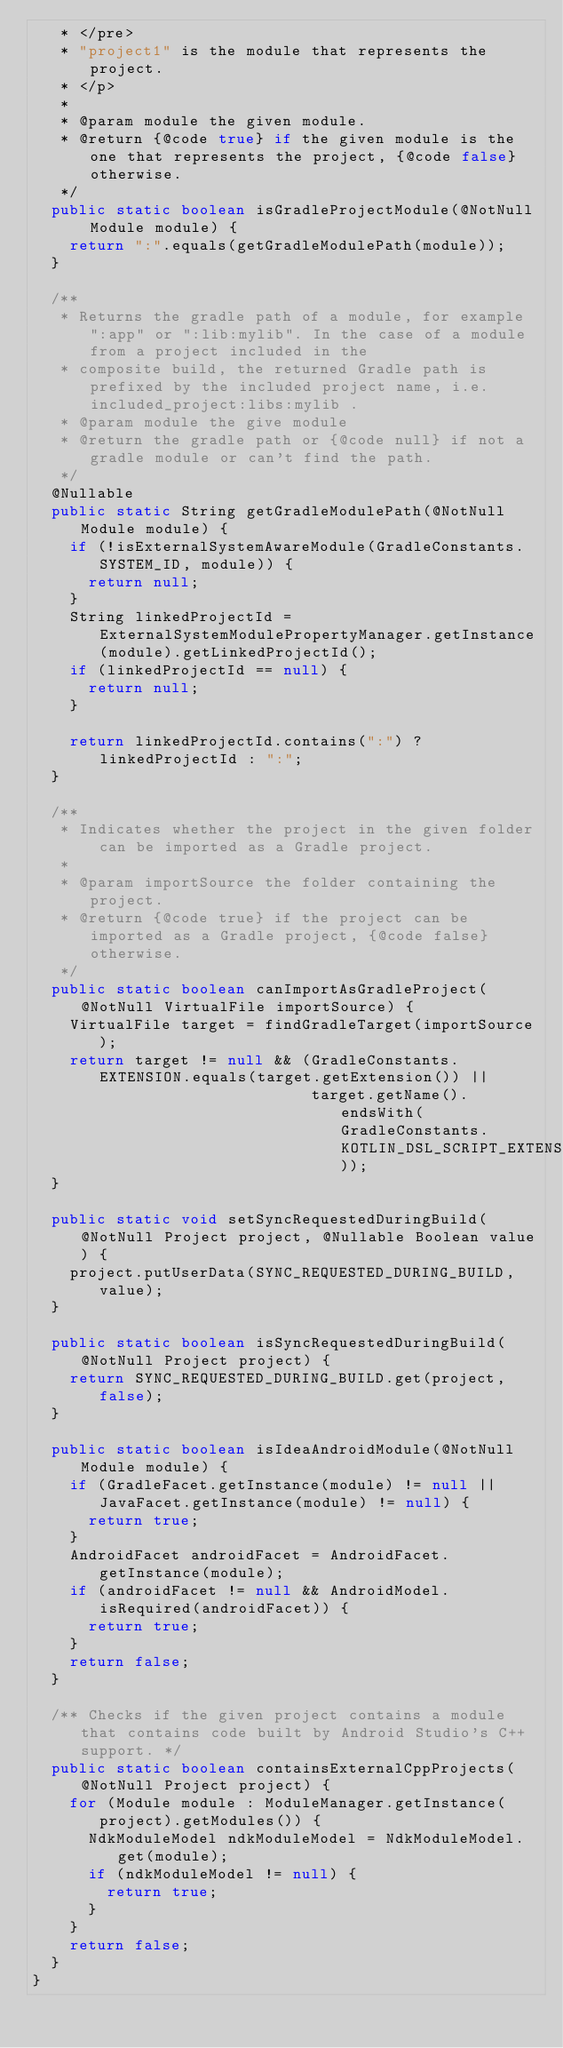Convert code to text. <code><loc_0><loc_0><loc_500><loc_500><_Java_>   * </pre>
   * "project1" is the module that represents the project.
   * </p>
   *
   * @param module the given module.
   * @return {@code true} if the given module is the one that represents the project, {@code false} otherwise.
   */
  public static boolean isGradleProjectModule(@NotNull Module module) {
    return ":".equals(getGradleModulePath(module));
  }

  /**
   * Returns the gradle path of a module, for example ":app" or ":lib:mylib". In the case of a module from a project included in the
   * composite build, the returned Gradle path is prefixed by the included project name, i.e. included_project:libs:mylib .
   * @param module the give module
   * @return the gradle path or {@code null} if not a gradle module or can't find the path.
   */
  @Nullable
  public static String getGradleModulePath(@NotNull Module module) {
    if (!isExternalSystemAwareModule(GradleConstants.SYSTEM_ID, module)) {
      return null;
    }
    String linkedProjectId = ExternalSystemModulePropertyManager.getInstance(module).getLinkedProjectId();
    if (linkedProjectId == null) {
      return null;
    }

    return linkedProjectId.contains(":") ? linkedProjectId : ":";
  }

  /**
   * Indicates whether the project in the given folder can be imported as a Gradle project.
   *
   * @param importSource the folder containing the project.
   * @return {@code true} if the project can be imported as a Gradle project, {@code false} otherwise.
   */
  public static boolean canImportAsGradleProject(@NotNull VirtualFile importSource) {
    VirtualFile target = findGradleTarget(importSource);
    return target != null && (GradleConstants.EXTENSION.equals(target.getExtension()) ||
                              target.getName().endsWith(GradleConstants.KOTLIN_DSL_SCRIPT_EXTENSION));
  }

  public static void setSyncRequestedDuringBuild(@NotNull Project project, @Nullable Boolean value) {
    project.putUserData(SYNC_REQUESTED_DURING_BUILD, value);
  }

  public static boolean isSyncRequestedDuringBuild(@NotNull Project project) {
    return SYNC_REQUESTED_DURING_BUILD.get(project, false);
  }

  public static boolean isIdeaAndroidModule(@NotNull Module module) {
    if (GradleFacet.getInstance(module) != null || JavaFacet.getInstance(module) != null) {
      return true;
    }
    AndroidFacet androidFacet = AndroidFacet.getInstance(module);
    if (androidFacet != null && AndroidModel.isRequired(androidFacet)) {
      return true;
    }
    return false;
  }

  /** Checks if the given project contains a module that contains code built by Android Studio's C++ support. */
  public static boolean containsExternalCppProjects(@NotNull Project project) {
    for (Module module : ModuleManager.getInstance(project).getModules()) {
      NdkModuleModel ndkModuleModel = NdkModuleModel.get(module);
      if (ndkModuleModel != null) {
        return true;
      }
    }
    return false;
  }
}
</code> 